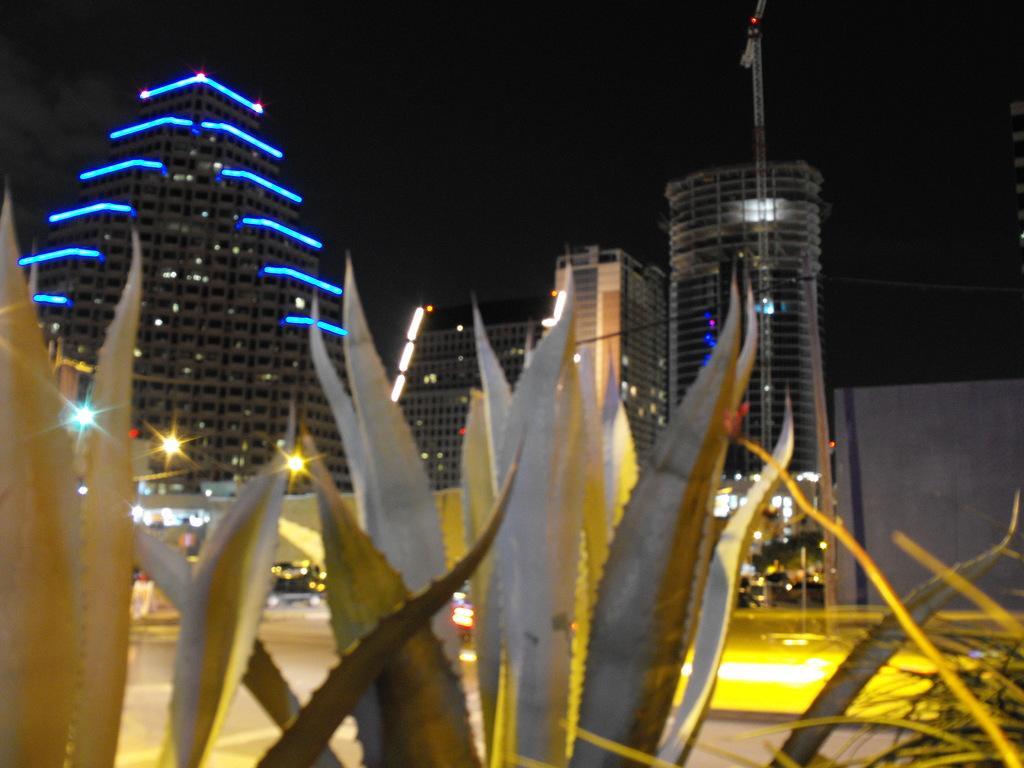In one or two sentences, can you explain what this image depicts? This picture shows few buildings and we see pole lights and few plants and lighting to the building. 